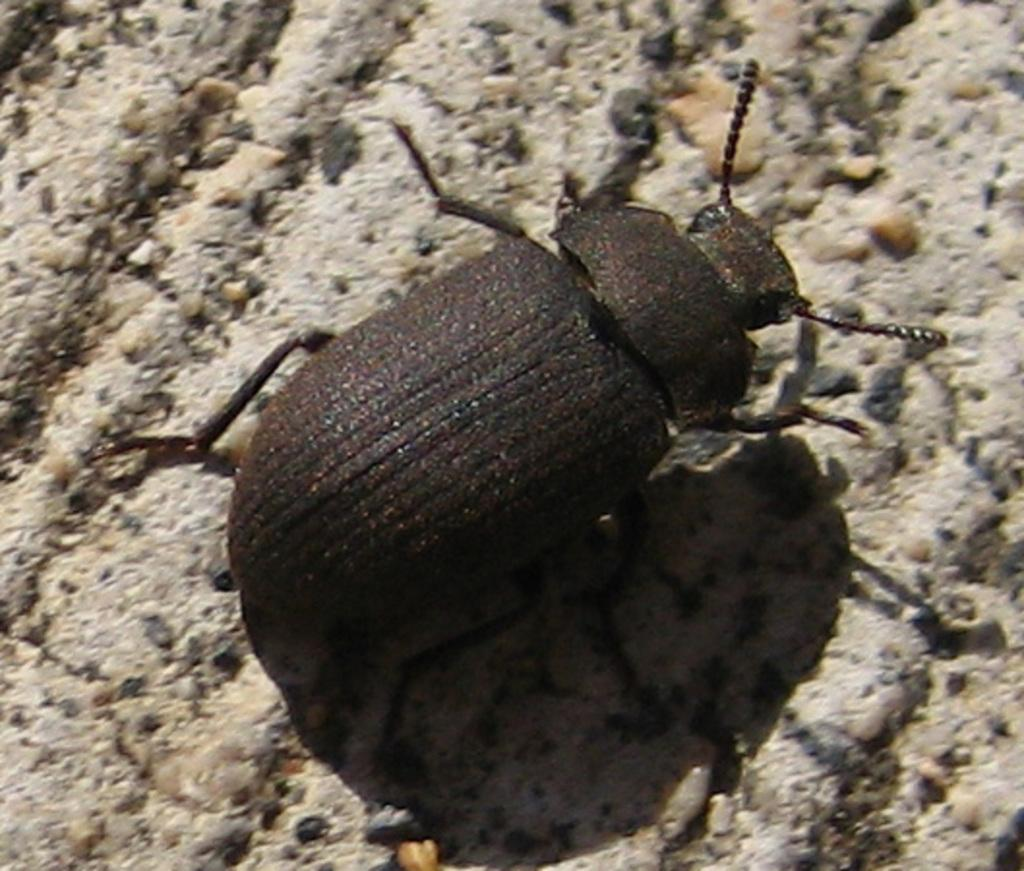What type of creature can be seen in the picture? There is a bug in the picture. Can you describe the bug's body parts? The bug has a head, body, and legs. What type of terrain is visible in the picture? There is soil, stones, and pebbles in the picture. What type of horn can be seen on the scarecrow in the picture? There is no scarecrow or horn present in the image. What is the bug writing on the pebbles in the picture? Bugs do not have the ability to write, and there are no signs of writing on the pebbles in the image. 